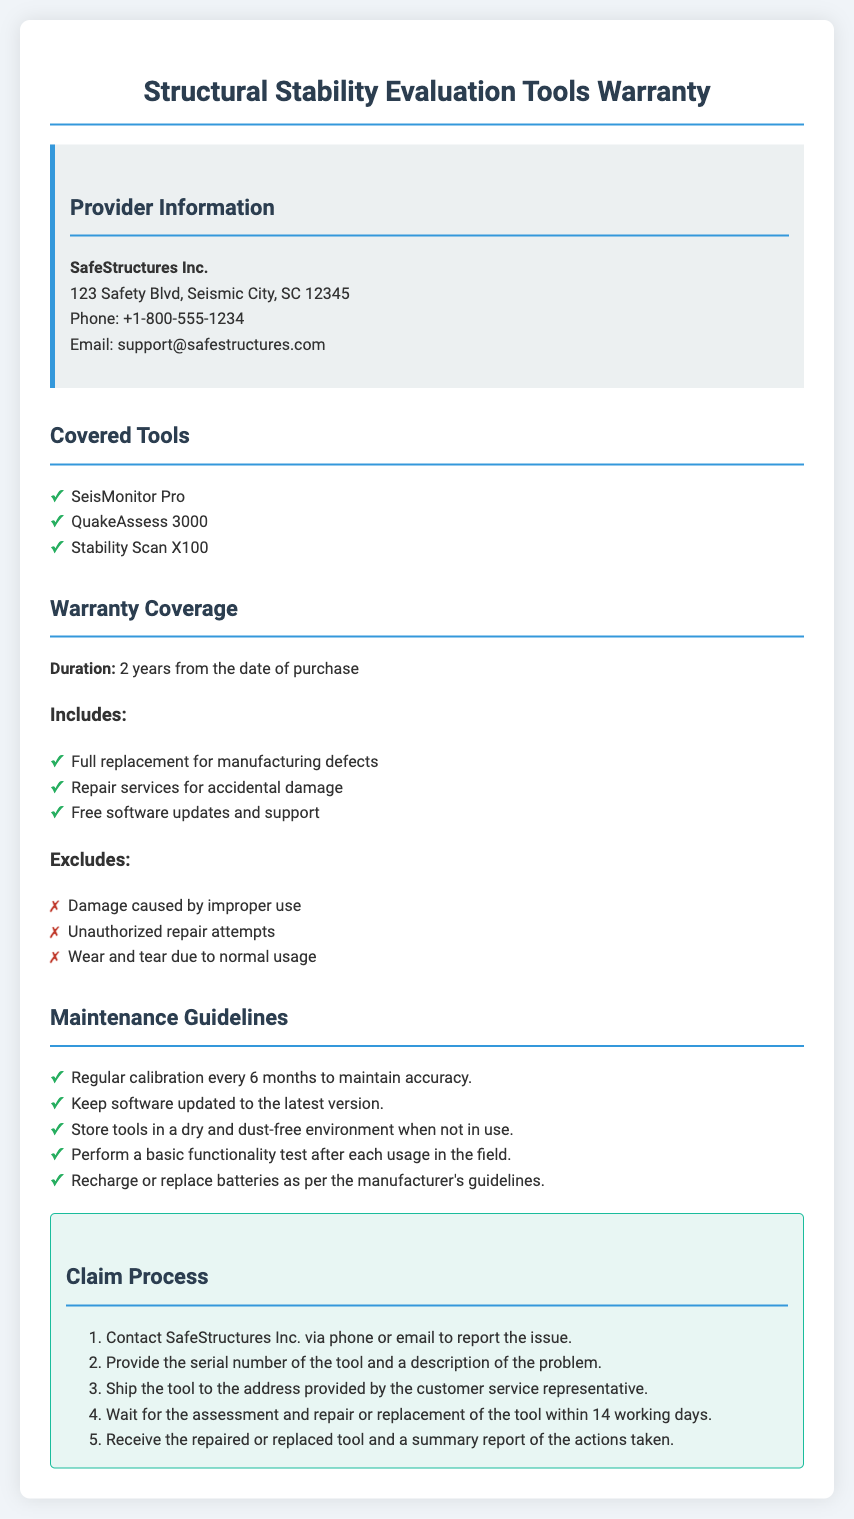what is the name of the provider? The name of the provider is listed in the document under the Provider Information section.
Answer: SafeStructures Inc how long is the warranty duration? The warranty duration is specified in the Warranty Coverage section of the document.
Answer: 2 years which tool is covered by the warranty? The document lists the covered tools under the Covered Tools section.
Answer: SeisMonitor Pro what type of damage is excluded from the warranty? The document outlines exclusions in the Warranty Coverage section that specify what types of damage are not covered.
Answer: Damage caused by improper use how often should calibration be performed? The Maintenance Guidelines section indicates the frequency for calibration.
Answer: Every 6 months what is the first step in the claim process? The Claim Process section provides a step-by-step guide starting with the initial action to take.
Answer: Contact SafeStructures Inc how many working days does the repair or replacement take? The timeframe for assessment and repair/replacement is mentioned in the Claim Process section.
Answer: 14 working days what should be done after each usage in the field? The document includes guidelines regarding actions to take after using the tools.
Answer: Perform a basic functionality test which service is included in the warranty? The warranty coverage includes specific services outlined in the Warranty Coverage section.
Answer: Repair services for accidental damage 